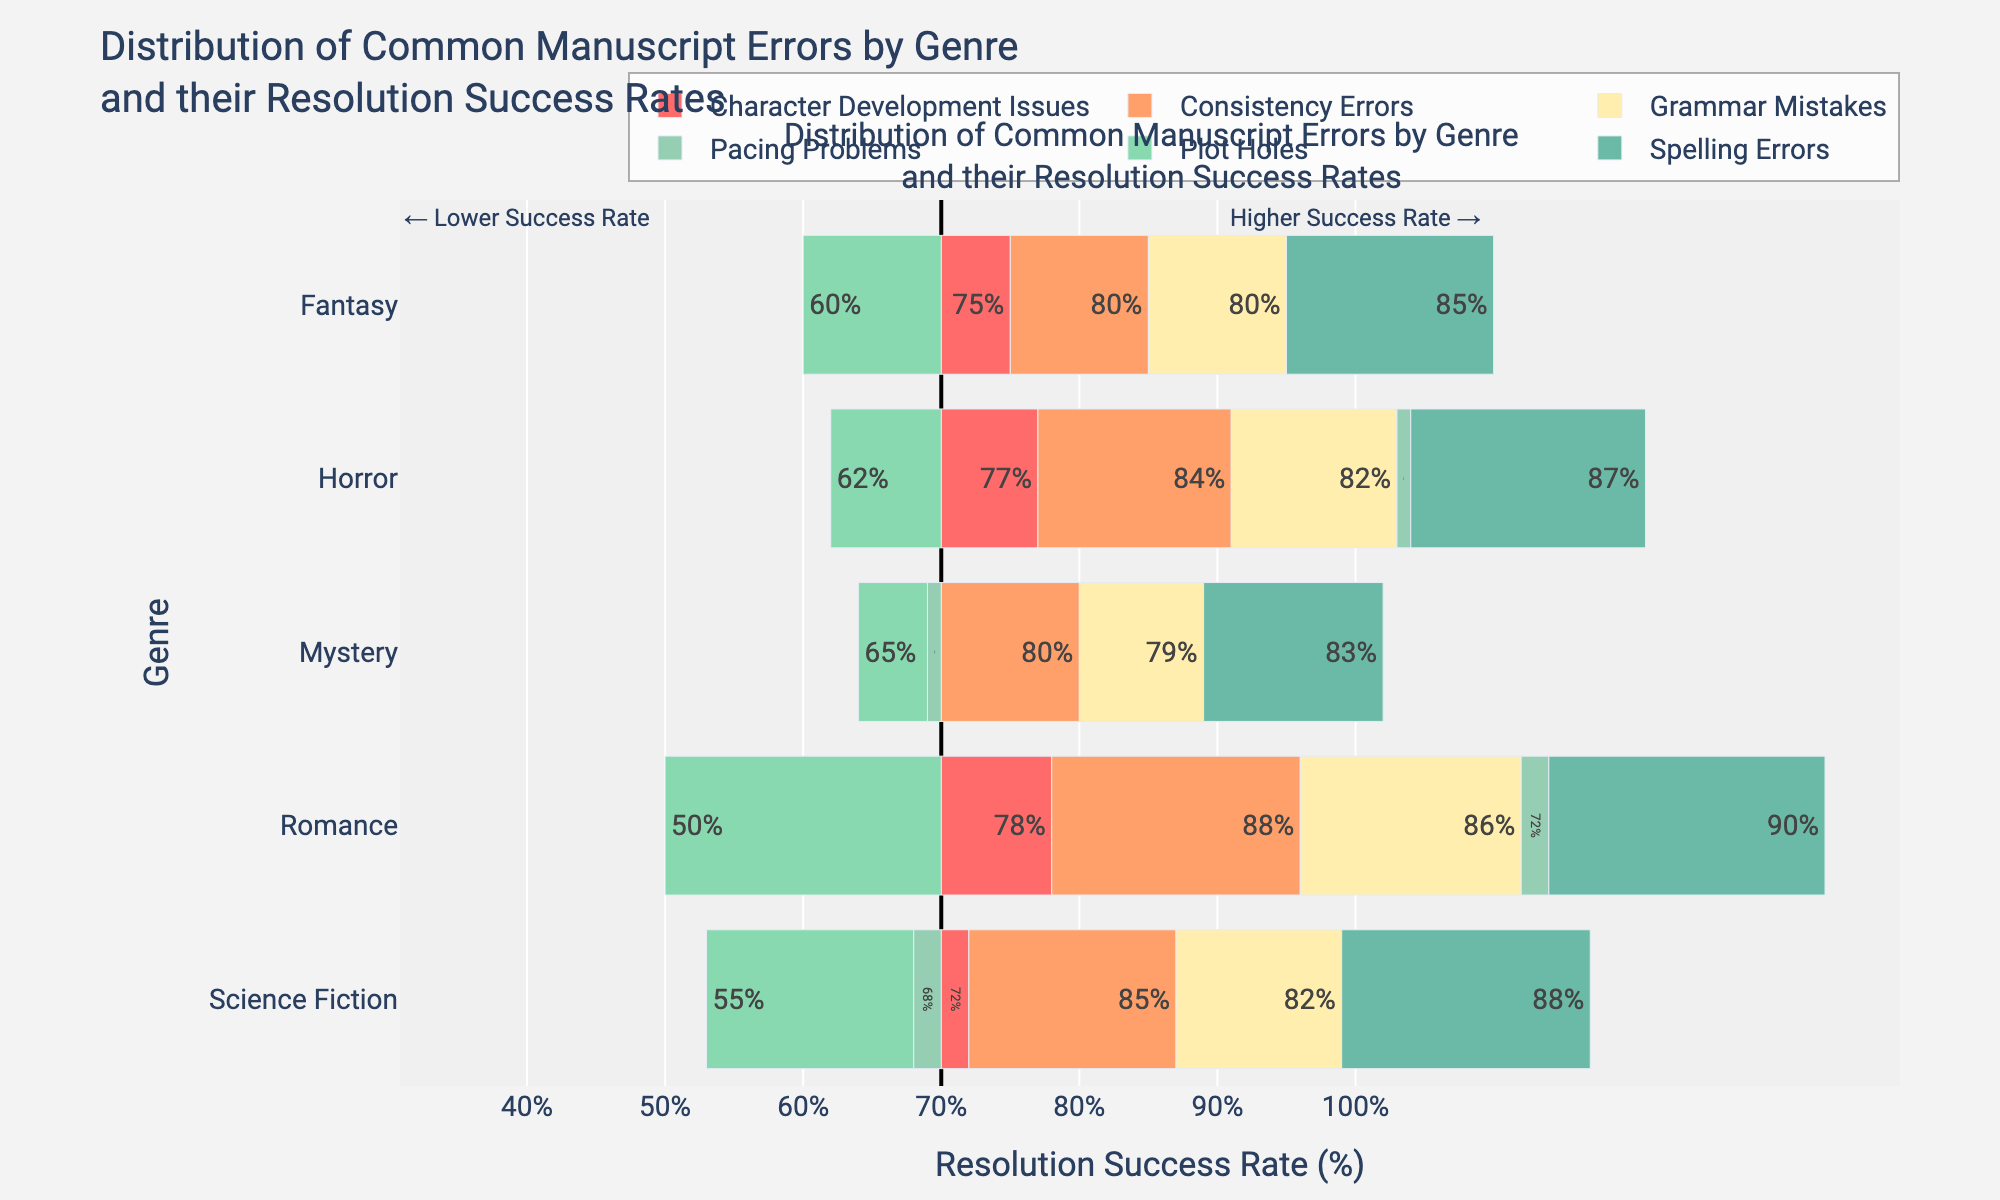What genre has the highest resolution success rate for spelling errors? To find the genre with the highest resolution success rate for spelling errors, look at the spelling errors bar segments and identify the genre with the longest bar in the positive direction. Romance has the longest bar in green, indicating the highest rate.
Answer: Romance Which error type has the lowest resolution success rate across all genres? To determine the error type with the lowest resolution success rate, look at the bar segments that extend the least to the right of the midpoint (70%). Plot holes consistently have the smallest lengths extending to the right of the midpoint in all genres.
Answer: Plot Holes Compare the resolution success rates of grammar mistakes between Fantasy and Horror. Which genre has a higher rate, and by how much? To compare the resolution success rates of grammar mistakes, find the red bar segments for Fantasy and Horror. Fantasy's grammar mistakes resolution rate is 80%, and Horror's is 82%. The difference is 82% - 80% = 2%.
Answer: Horror by 2% Which genre has the most consistent resolution success rate for all error types? To identify the genre with the most consistent resolution success rate, inspect the lengths of bar segments within each genre. Mystery shows minimal variation, indicating consistency.
Answer: Mystery Calculate the average resolution success rate of pacing problems for all genres. To find the average resolution success rate for pacing problems, sum the rates for all genres and divide by the number of genres. The rates are 70%, 68%, 72%, 69%, and 71%. The sum is 350%, and the average is 350% / 5 = 70%.
Answer: 70% Which error type in Science Fiction has the highest resolution success rate, and how does it compare to the same error type in Fantasy? Identify the error type in Science Fiction with the longest bar segment to the right of the midpoint. Spelling Errors in Science Fiction have a 88% resolution success rate. In Fantasy, Spelling Errors have a resolution success rate of 85%, so Science Fiction’s rate is higher by 3%.
Answer: Spelling Errors, 3% higher How does the resolution success rate of character development issues in Romance compare to that in Mystery? Look at the yellow bar segments for character development issues in Romance and Mystery. Romance has a resolution success rate of 78%, while Mystery has 70%. Therefore, Romance is higher by 8%.
Answer: Romance by 8% If we sum the resolution success rates for plot holes across all genres, what is the total? Sum the resolution success rates of plot holes for each genre: 60% (Fantasy), 55% (Science Fiction), 50% (Romance), 65% (Mystery), and 62% (Horror). The total is 60 + 55 + 50 + 65 + 62 = 292%.
Answer: 292% What is the average resolution success rate for consistency errors in Fantasy and Science Fiction? To find the average, add the resolution success rates for consistency errors in Fantasy (80%) and Science Fiction (85%), then divide by 2. The sum is 80 + 85 = 165, and the average is 165 / 2 = 82.5%.
Answer: 82.5% Which genre has the lowest average resolution success rate across all error types? To find the genre with the lowest average rate, calculate the average rate for all error types within each genre and compare. Calculate each genre’s rate: Fantasy (75%), Science Fiction (75.67%), Romance (77.33%), Mystery (74.33%), and Horror (77.17%). Fantasy, with an average of 75%, has the lowest.
Answer: Fantasy 